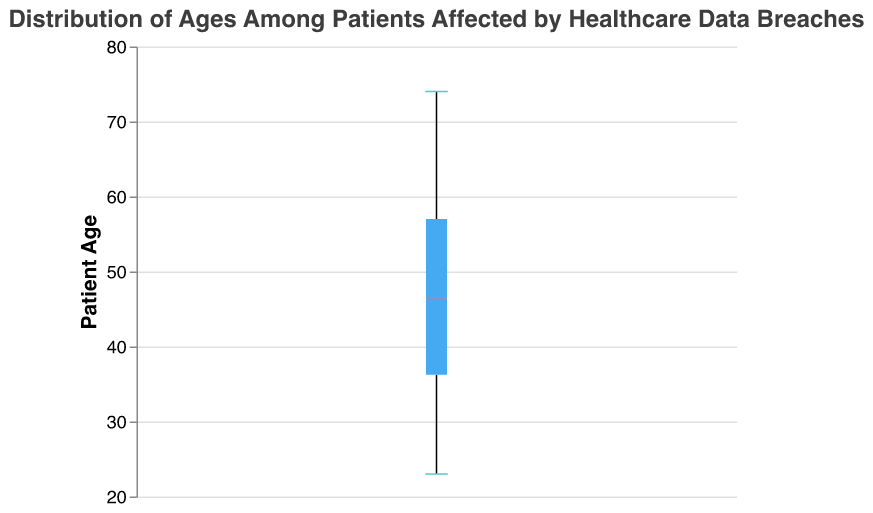What is the title of the figure? The title is displayed at the top of the figure and provides a brief description of what the figure represents.
Answer: Distribution of Ages Among Patients Affected by Healthcare Data Breaches What is the median age of the patients? The median age is represented by a line inside the box of the box plot with a specific color. Identify the color and the corresponding age value.
Answer: 50 How many patients are represented in the figure? Count the number of unique data points listed and match it to the total number shown in the figure.
Answer: 20 What is the range of ages among the patients? The range can be determined by looking at the minimum and maximum age values represented by the whiskers of the box plot.
Answer: 23 to 74 What is the interquartile range (IQR) of the ages? The IQR is the range between the first quartile (Q1) and the third quartile (Q3), represented by the edges of the box.
Answer: 37 to 62, so IQR = 25 What age is represented at the lower whisker? The lower whisker indicates the minimum age value in the dataset.
Answer: 23 What age is represented at the upper whisker? The upper whisker indicates the maximum age value in the dataset.
Answer: 74 How does the upper quartile (Q3) compare to the median age? The upper quartile (Q3) is located at the edge of the box towards the upper side. Compare this value to the median line within the box.
Answer: Q3 is higher than the median age; Q3 is 62, median is 50 Is there any outlier in the data? Outliers are data points that lie outside the whiskers of the box plot. Identify if there are any dots outside the whiskers.
Answer: No What is the middle 50% range of ages? The middle 50% range, or interquartile range (IQR), is within the box, between Q1 and Q3.
Answer: 37 to 62 